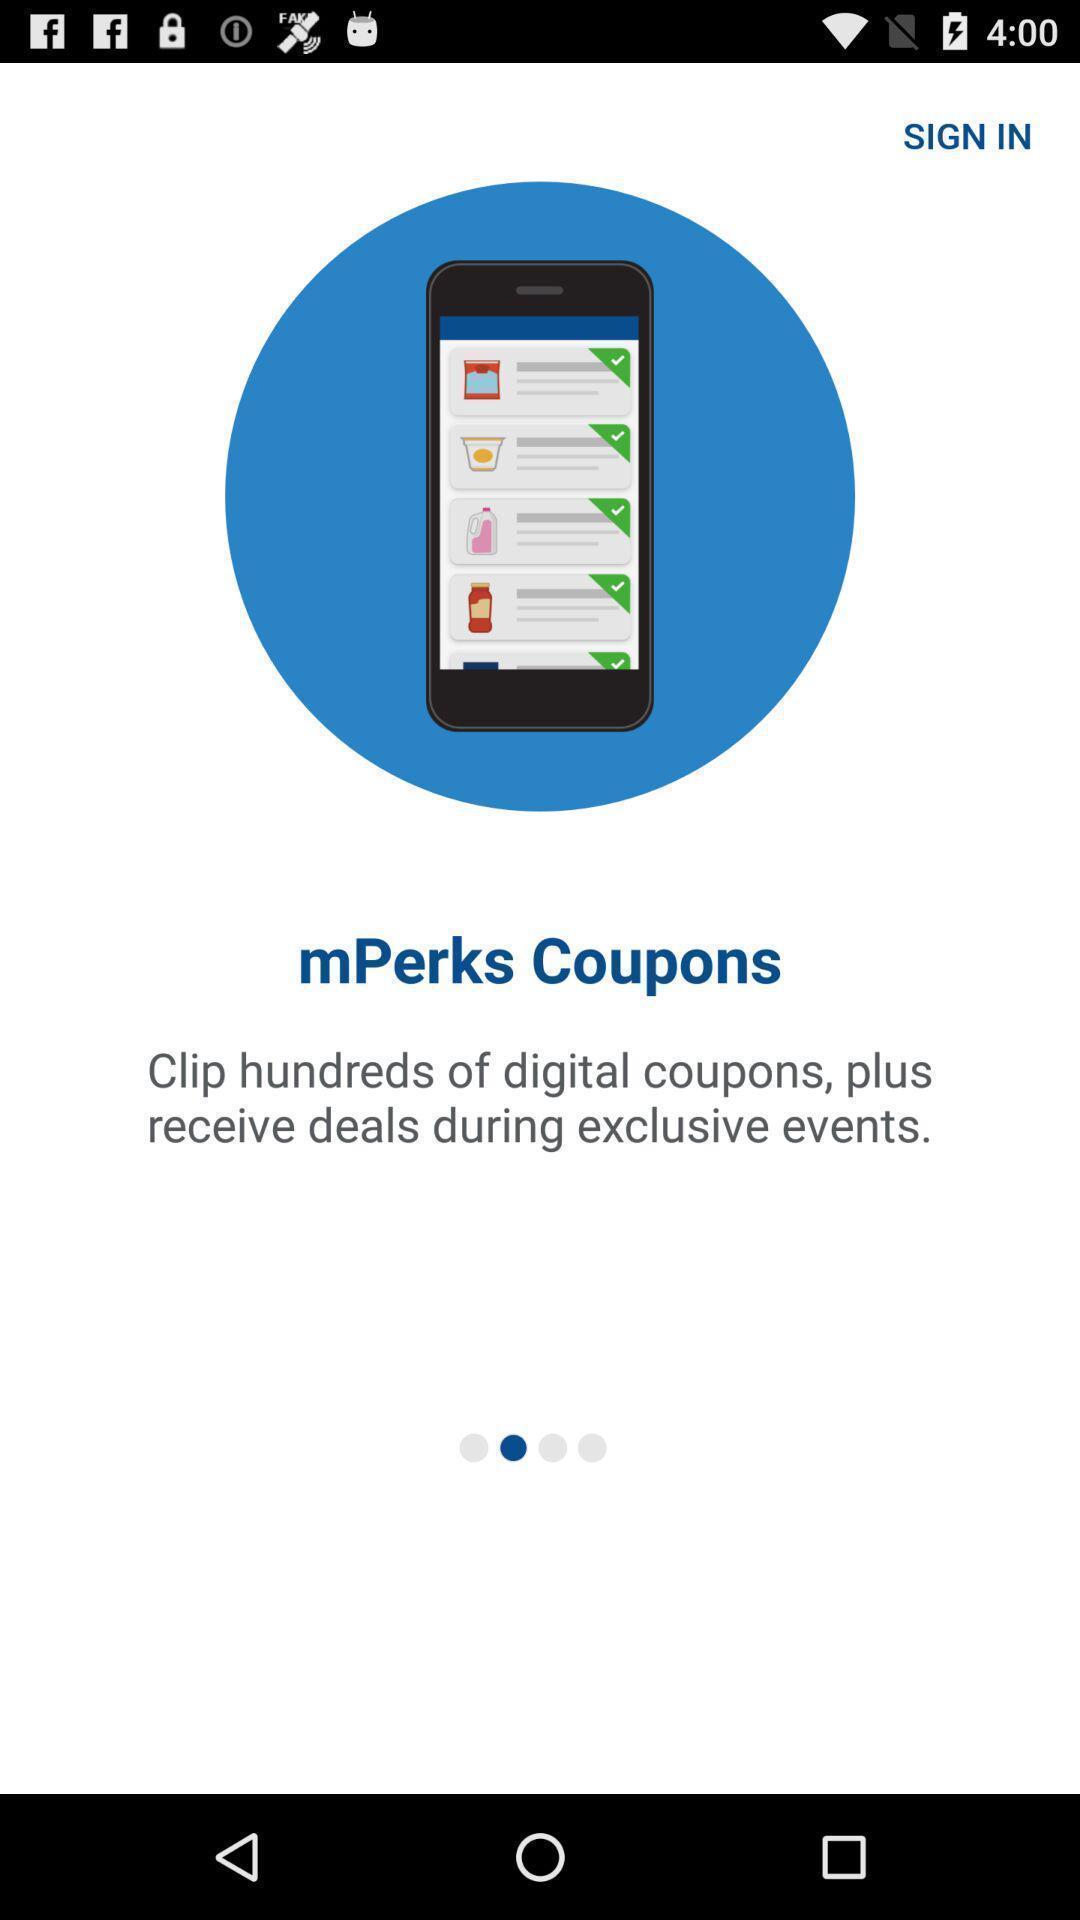Tell me about the visual elements in this screen capture. Welcome page of shopping app. 